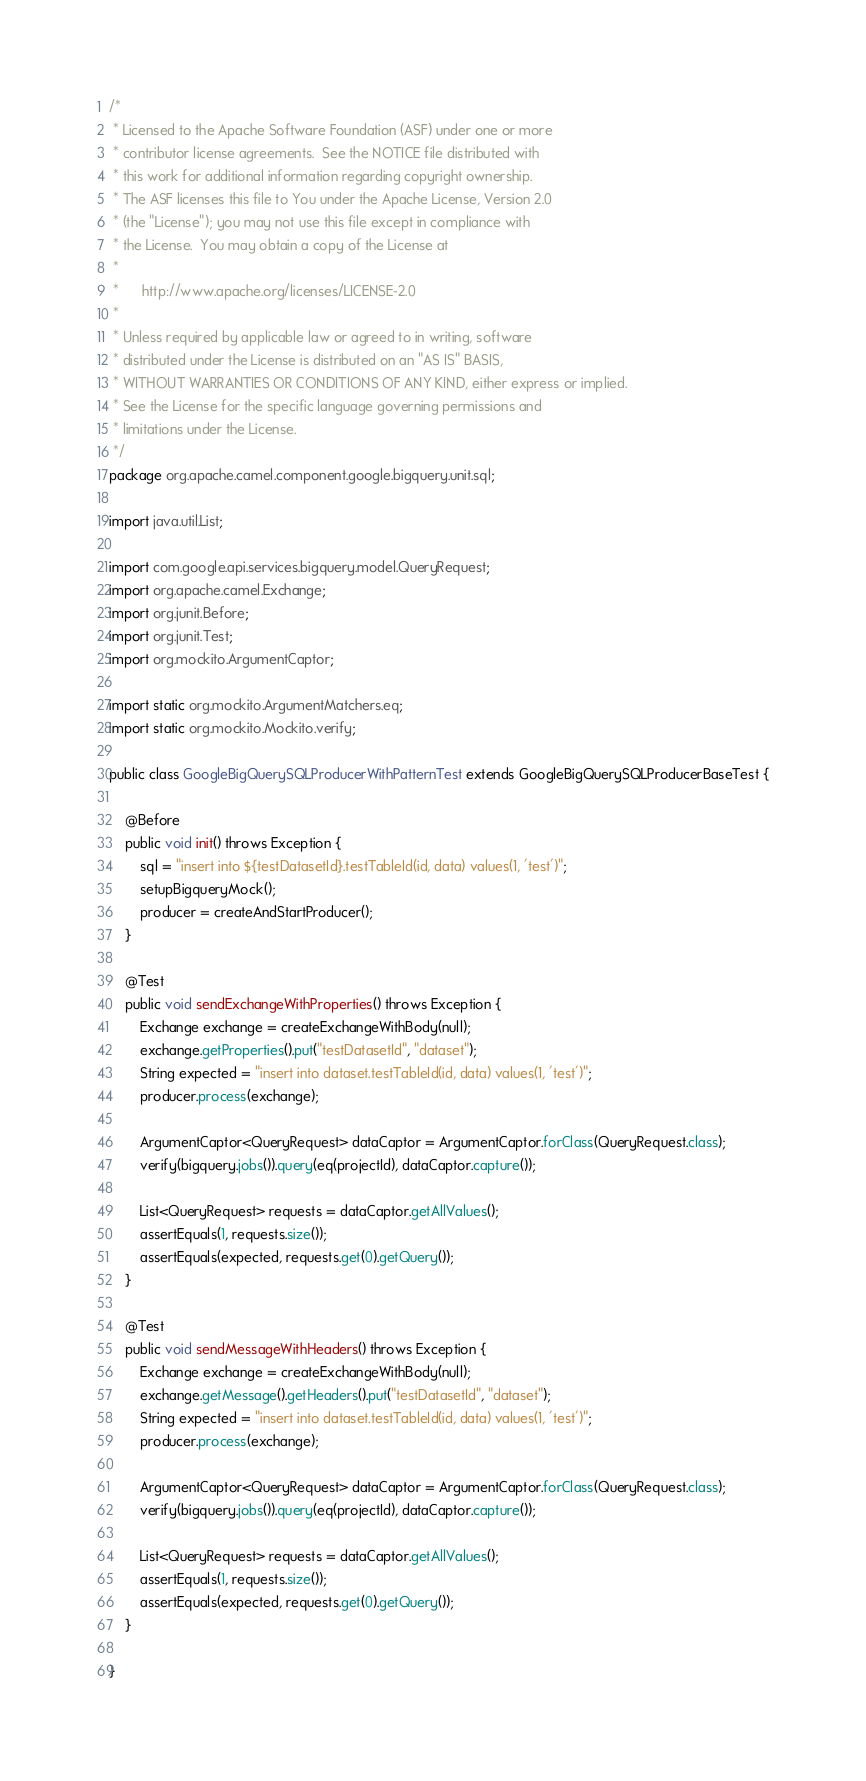<code> <loc_0><loc_0><loc_500><loc_500><_Java_>/*
 * Licensed to the Apache Software Foundation (ASF) under one or more
 * contributor license agreements.  See the NOTICE file distributed with
 * this work for additional information regarding copyright ownership.
 * The ASF licenses this file to You under the Apache License, Version 2.0
 * (the "License"); you may not use this file except in compliance with
 * the License.  You may obtain a copy of the License at
 *
 *      http://www.apache.org/licenses/LICENSE-2.0
 *
 * Unless required by applicable law or agreed to in writing, software
 * distributed under the License is distributed on an "AS IS" BASIS,
 * WITHOUT WARRANTIES OR CONDITIONS OF ANY KIND, either express or implied.
 * See the License for the specific language governing permissions and
 * limitations under the License.
 */
package org.apache.camel.component.google.bigquery.unit.sql;

import java.util.List;

import com.google.api.services.bigquery.model.QueryRequest;
import org.apache.camel.Exchange;
import org.junit.Before;
import org.junit.Test;
import org.mockito.ArgumentCaptor;

import static org.mockito.ArgumentMatchers.eq;
import static org.mockito.Mockito.verify;

public class GoogleBigQuerySQLProducerWithPatternTest extends GoogleBigQuerySQLProducerBaseTest {

    @Before
    public void init() throws Exception {
        sql = "insert into ${testDatasetId}.testTableId(id, data) values(1, 'test')";
        setupBigqueryMock();
        producer = createAndStartProducer();
    }

    @Test
    public void sendExchangeWithProperties() throws Exception {
        Exchange exchange = createExchangeWithBody(null);
        exchange.getProperties().put("testDatasetId", "dataset");
        String expected = "insert into dataset.testTableId(id, data) values(1, 'test')";
        producer.process(exchange);

        ArgumentCaptor<QueryRequest> dataCaptor = ArgumentCaptor.forClass(QueryRequest.class);
        verify(bigquery.jobs()).query(eq(projectId), dataCaptor.capture());

        List<QueryRequest> requests = dataCaptor.getAllValues();
        assertEquals(1, requests.size());
        assertEquals(expected, requests.get(0).getQuery());
    }

    @Test
    public void sendMessageWithHeaders() throws Exception {
        Exchange exchange = createExchangeWithBody(null);
        exchange.getMessage().getHeaders().put("testDatasetId", "dataset");
        String expected = "insert into dataset.testTableId(id, data) values(1, 'test')";
        producer.process(exchange);

        ArgumentCaptor<QueryRequest> dataCaptor = ArgumentCaptor.forClass(QueryRequest.class);
        verify(bigquery.jobs()).query(eq(projectId), dataCaptor.capture());

        List<QueryRequest> requests = dataCaptor.getAllValues();
        assertEquals(1, requests.size());
        assertEquals(expected, requests.get(0).getQuery());
    }

}
</code> 